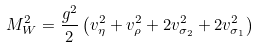<formula> <loc_0><loc_0><loc_500><loc_500>M _ { W } ^ { 2 } = \frac { g ^ { 2 } } { 2 } \left ( v _ { \eta } ^ { 2 } + v _ { \rho } ^ { 2 } + 2 v _ { \sigma _ { 2 } } ^ { 2 } + 2 v _ { \sigma _ { 1 } } ^ { 2 } \right )</formula> 